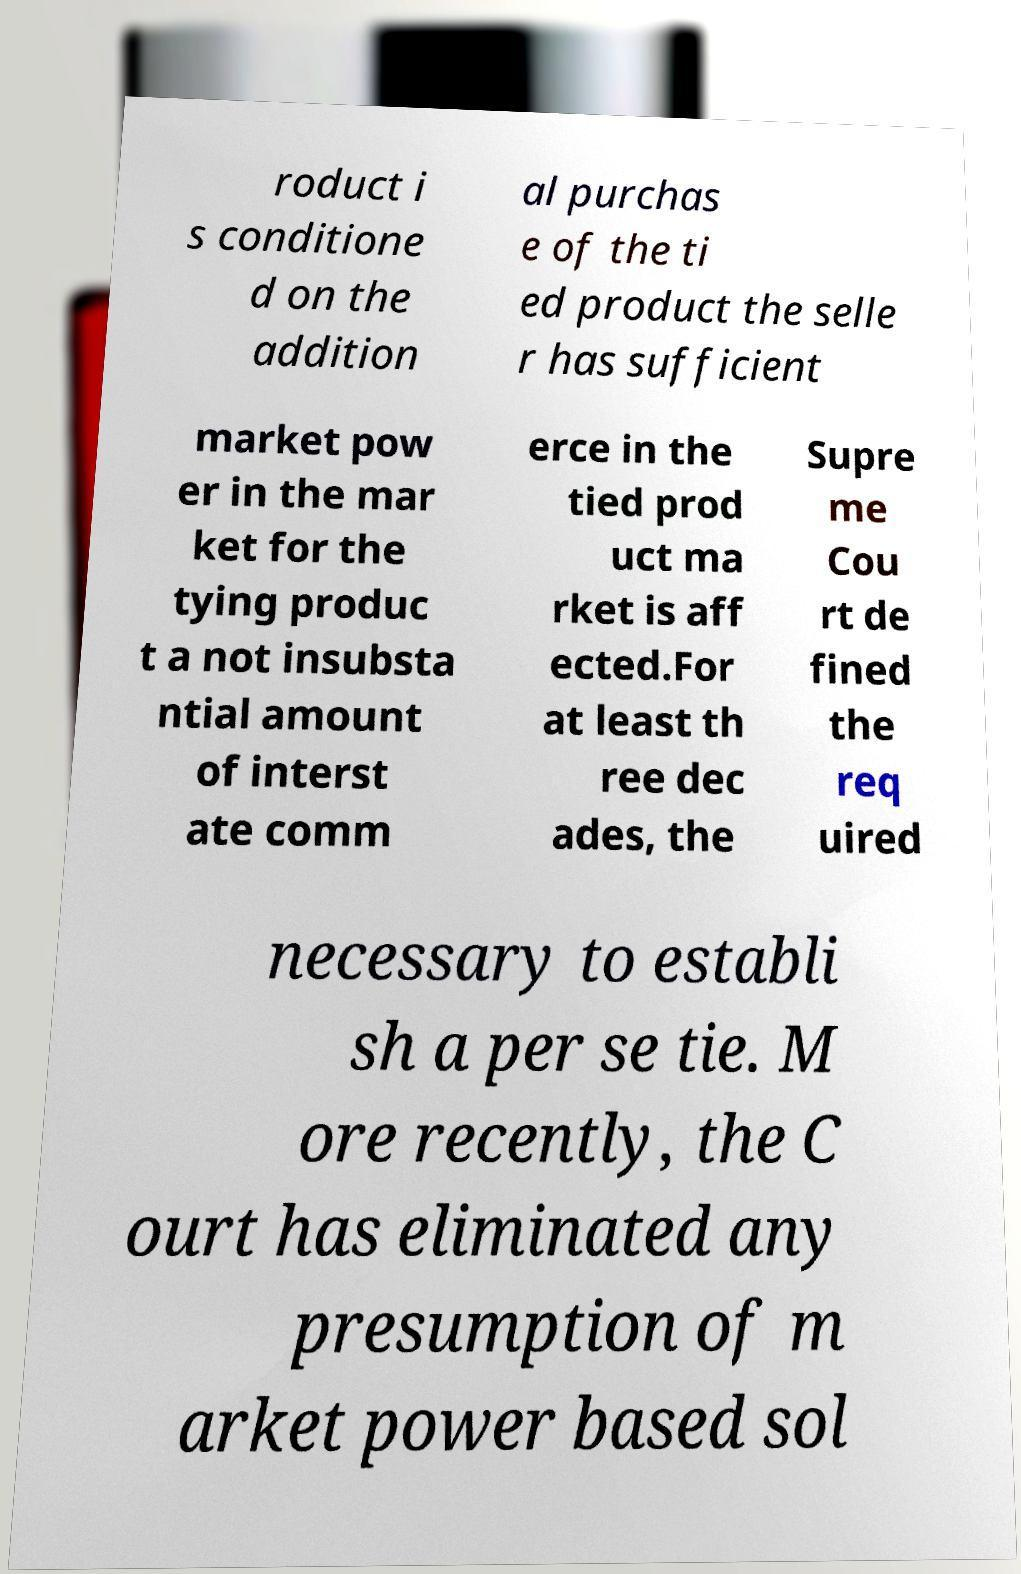Can you accurately transcribe the text from the provided image for me? roduct i s conditione d on the addition al purchas e of the ti ed product the selle r has sufficient market pow er in the mar ket for the tying produc t a not insubsta ntial amount of interst ate comm erce in the tied prod uct ma rket is aff ected.For at least th ree dec ades, the Supre me Cou rt de fined the req uired necessary to establi sh a per se tie. M ore recently, the C ourt has eliminated any presumption of m arket power based sol 